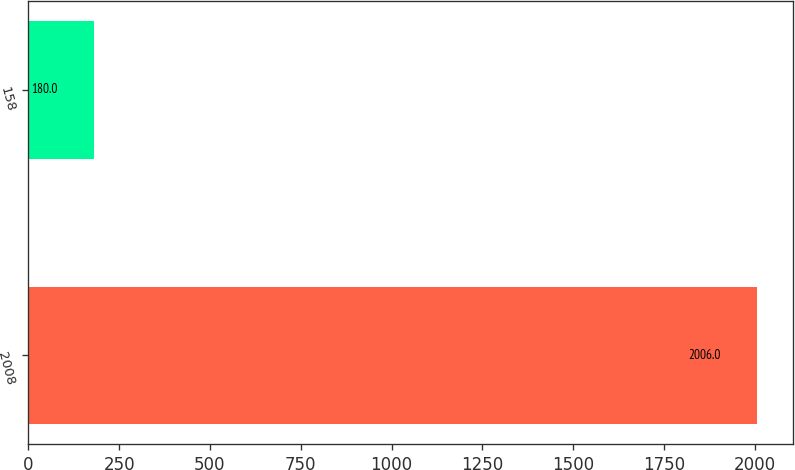<chart> <loc_0><loc_0><loc_500><loc_500><bar_chart><fcel>2008<fcel>158<nl><fcel>2006<fcel>180<nl></chart> 